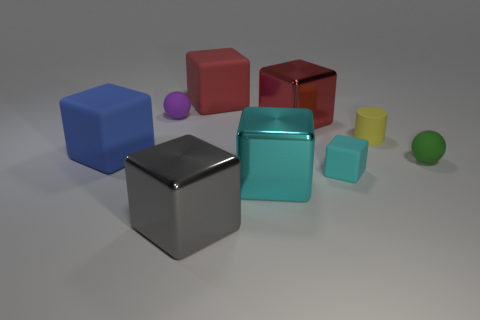Subtract all large cyan cubes. How many cubes are left? 5 Subtract 1 balls. How many balls are left? 1 Subtract all red cubes. How many cubes are left? 4 Subtract all blocks. How many objects are left? 3 Subtract all brown balls. Subtract all cyan cylinders. How many balls are left? 2 Subtract all yellow spheres. How many purple cubes are left? 0 Subtract all spheres. Subtract all large blue rubber things. How many objects are left? 6 Add 1 big gray metallic blocks. How many big gray metallic blocks are left? 2 Add 7 big blue cubes. How many big blue cubes exist? 8 Subtract 0 brown cubes. How many objects are left? 9 